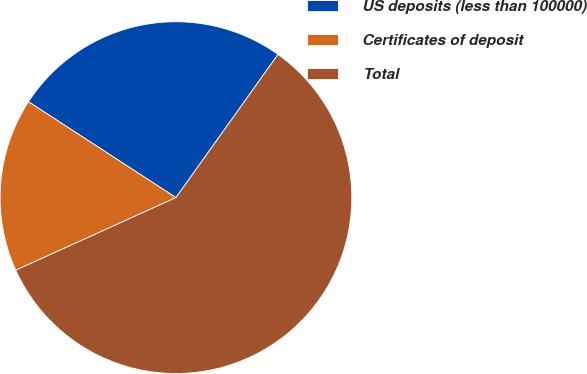<chart> <loc_0><loc_0><loc_500><loc_500><pie_chart><fcel>US deposits (less than 100000)<fcel>Certificates of deposit<fcel>Total<nl><fcel>25.68%<fcel>15.95%<fcel>58.37%<nl></chart> 